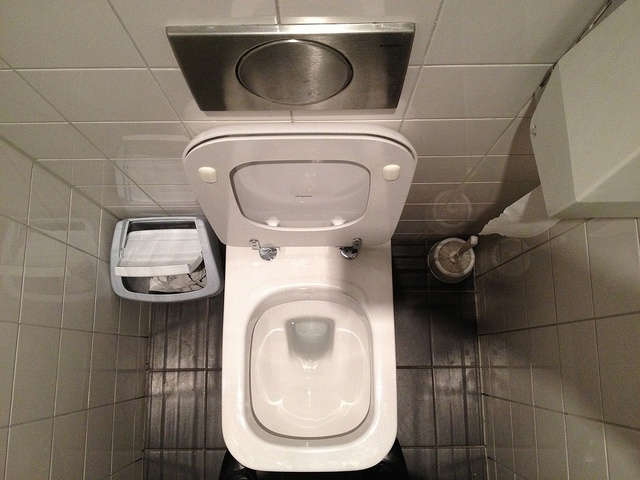Describe the objects in this image and their specific colors. I can see a toilet in gray, lightgray, and darkgray tones in this image. 